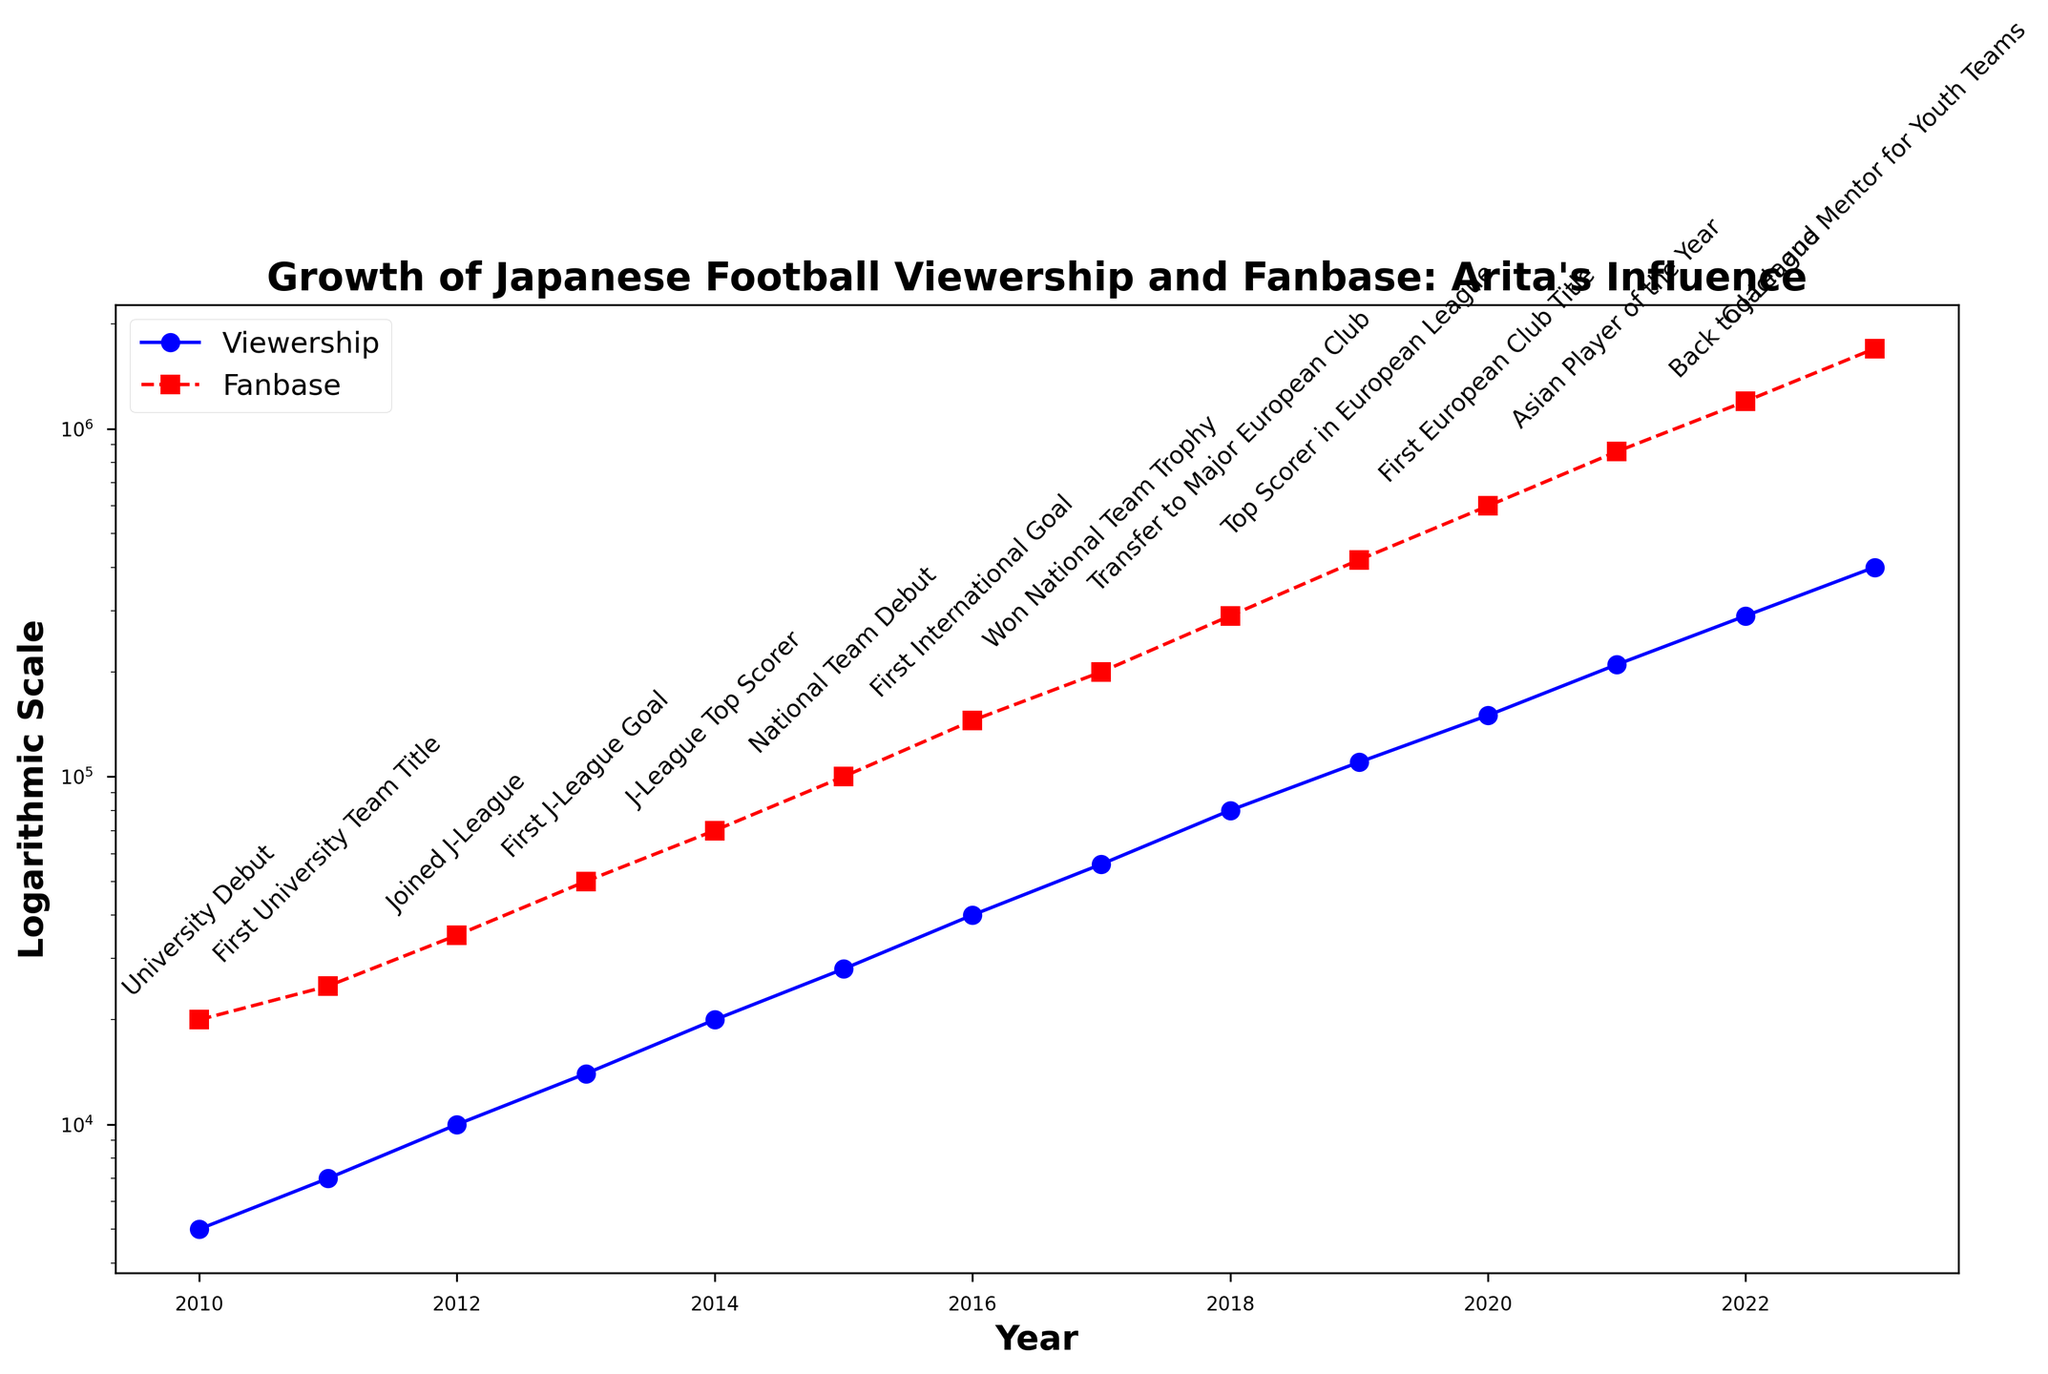What trend is observed in the viewership and fanbase from 2010 to 2023? The chart shows both viewership and fanbase growing significantly from 2010 to 2023. Viewership starts at 5,000 in 2010 and reaches 400,000 by 2023, while fanbase grows from 20,000 in 2010 to 1,700,000 by 2023.
Answer: Significant growth In which years did the viewership exceed 50,000? According to the figure, viewership exceeded 50,000 starting in 2017 and onwards. Each year after 2017 shows a viewership higher than this threshold.
Answer: 2017-2023 Which year marked the highest increase in fanbase? To find the highest increase, compare the fanbase changes year-over-year. The increase from 2022 (1,200,000) to 2023 (1,700,000) is the largest, a change of 500,000.
Answer: 2023 How does the fanbase in 2022 compare to that in 2011? Fanbase in 2022 is 1,200,000 whereas in 2011 it was 25,000. The difference is 1,200,000 - 25,000 = 1,175,000.
Answer: 1,175,000 increase Which event correlates with the largest increase in viewership? First, identify all the major career events and correlate each with the viewership increase of that year. The largest increase is from 2018 to 2019, coinciding with "Top Scorer in European League."
Answer: Top Scorer in European League What is the average yearly growth rate in fanbase between 2010 and 2015? Find the total growth over the period (100,000 - 20,000 = 80,000). There are 5 years between 2010 and 2015. The average yearly growth is 80,000 / 5 = 16,000.
Answer: 16,000 How does the visual representation distinguish between viewership and fanbase trends? The viewership is represented with a blue line and circular markers, while the fanbase is represented with a red dashed line and square markers.
Answer: Blue vs Red In what year did the fanbase first exceed 500,000? The graph shows 2020 as the year when the fanbase first exceeds 500,000.
Answer: 2020 What was the impact on viewership when Arita returned to the J-League in 2022? Viewership increased from 290,000 (2022) to 400,000 (2023) after Arita returned to the J-League.
Answer: 110,000 increase Which year experienced both significant career events and notable increase in fanbase? 2018 shows both a major career event, "Transfer to Major European Club," and a significant fanbase increase from 200,000 to 290,000.
Answer: 2018 